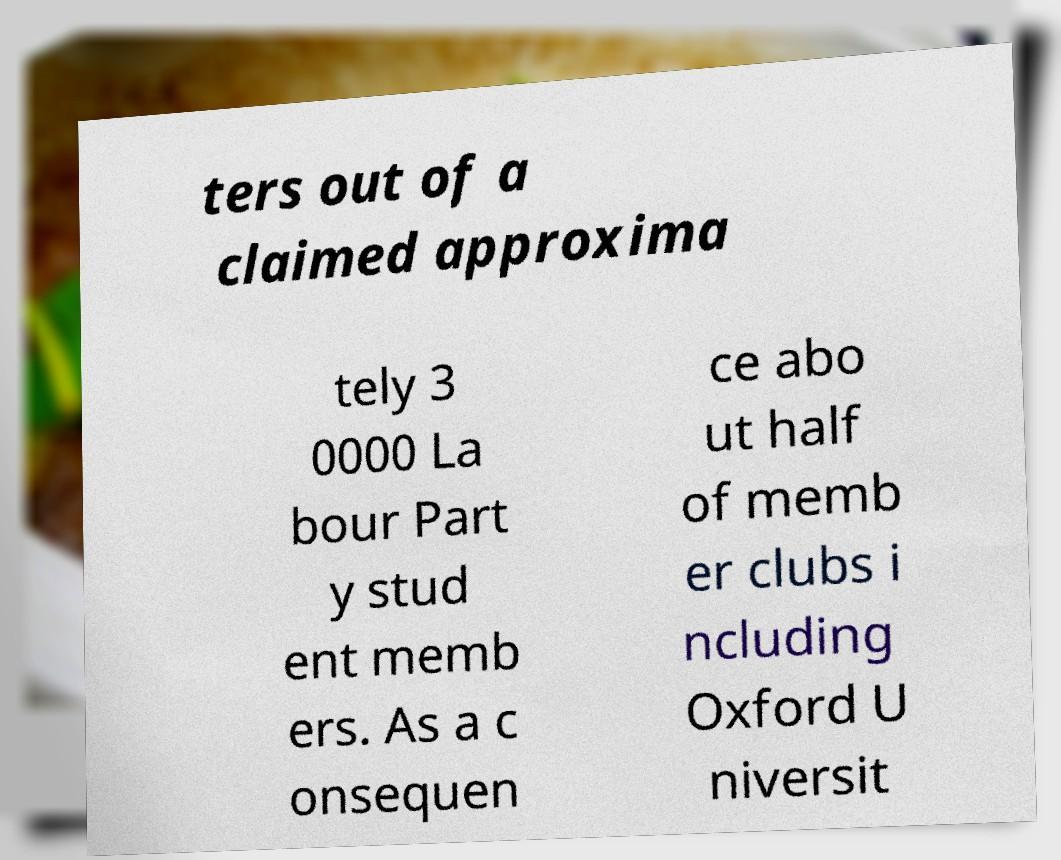What messages or text are displayed in this image? I need them in a readable, typed format. ters out of a claimed approxima tely 3 0000 La bour Part y stud ent memb ers. As a c onsequen ce abo ut half of memb er clubs i ncluding Oxford U niversit 